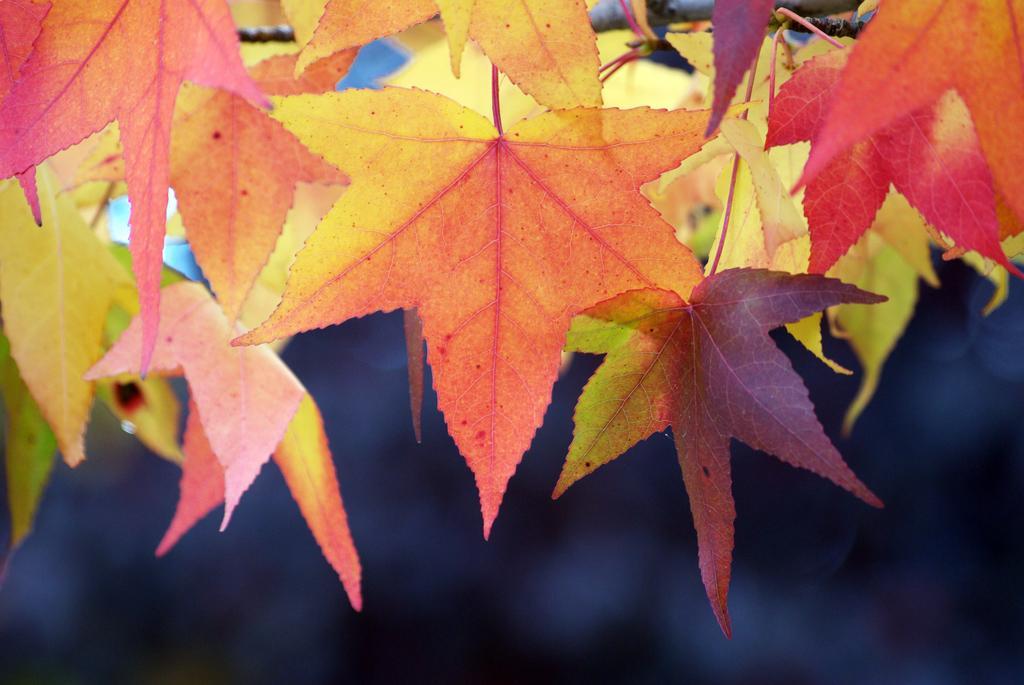In one or two sentences, can you explain what this image depicts? In this picture, we can see leaves which are in orange color, at the bottom, we can see black color. 